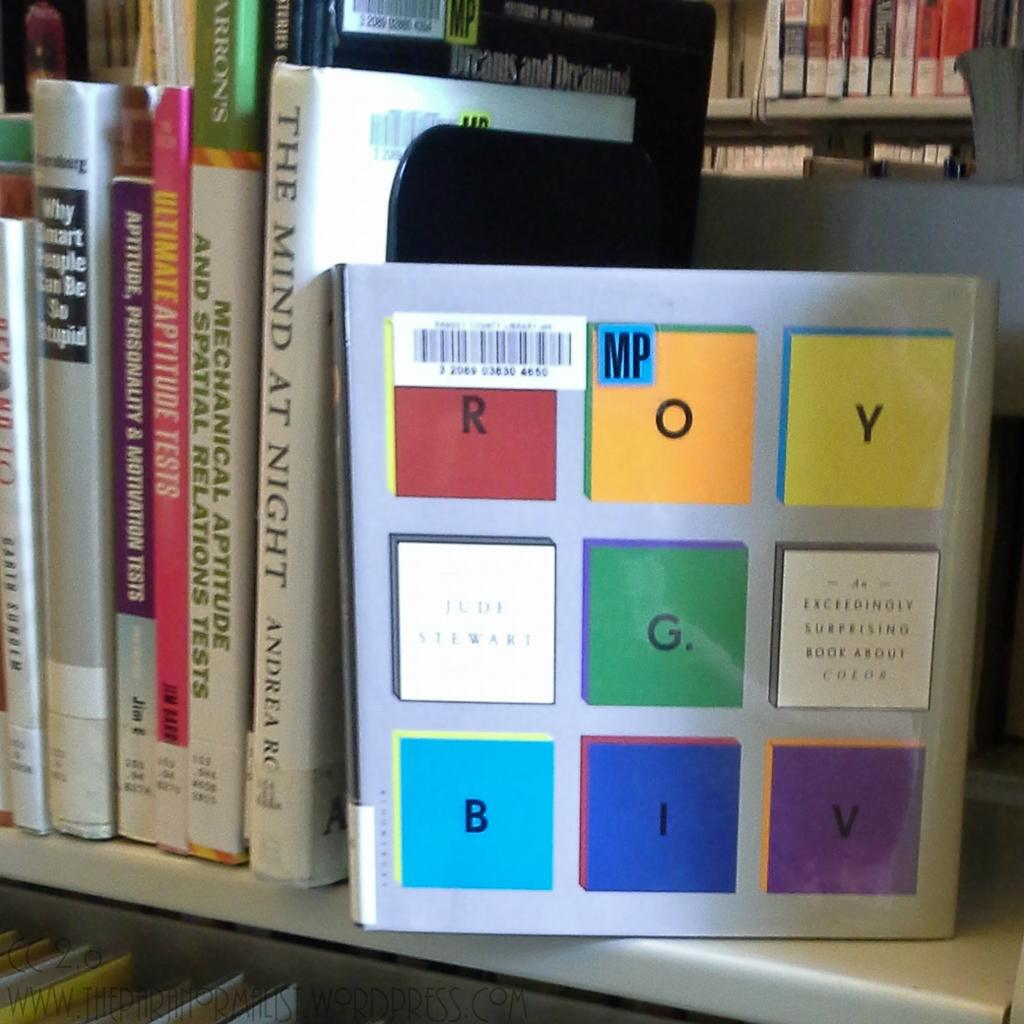<image>
Summarize the visual content of the image. a shelf with a stack of books including the mind at night 